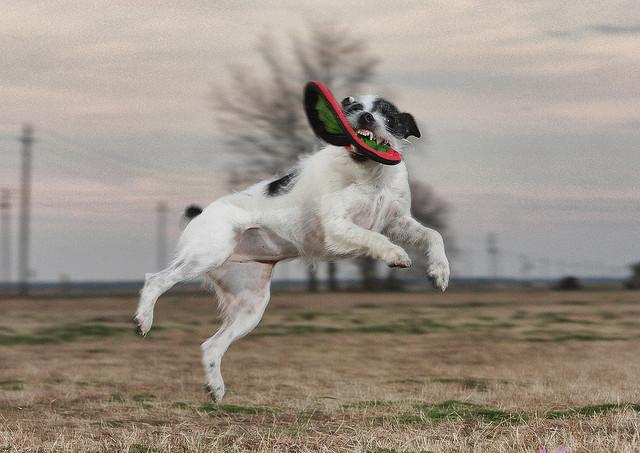Does the dog look mad?
Be succinct. Yes. What is the dog holding in his mouth?
Short answer required. Frisbee. How many of the dogs feet are touching the ground?
Write a very short answer. 0. Is the horse leaping in the air?
Quick response, please. No. What is the dog catching?
Answer briefly. Frisbee. Is this dog athletic?
Be succinct. Yes. Does the dog cast a shadow?
Keep it brief. No. How many dogs?
Write a very short answer. 1. What is the dog playing with?
Give a very brief answer. Frisbee. What color is the dog?
Concise answer only. White and black. Is this dog overweight?
Give a very brief answer. No. 